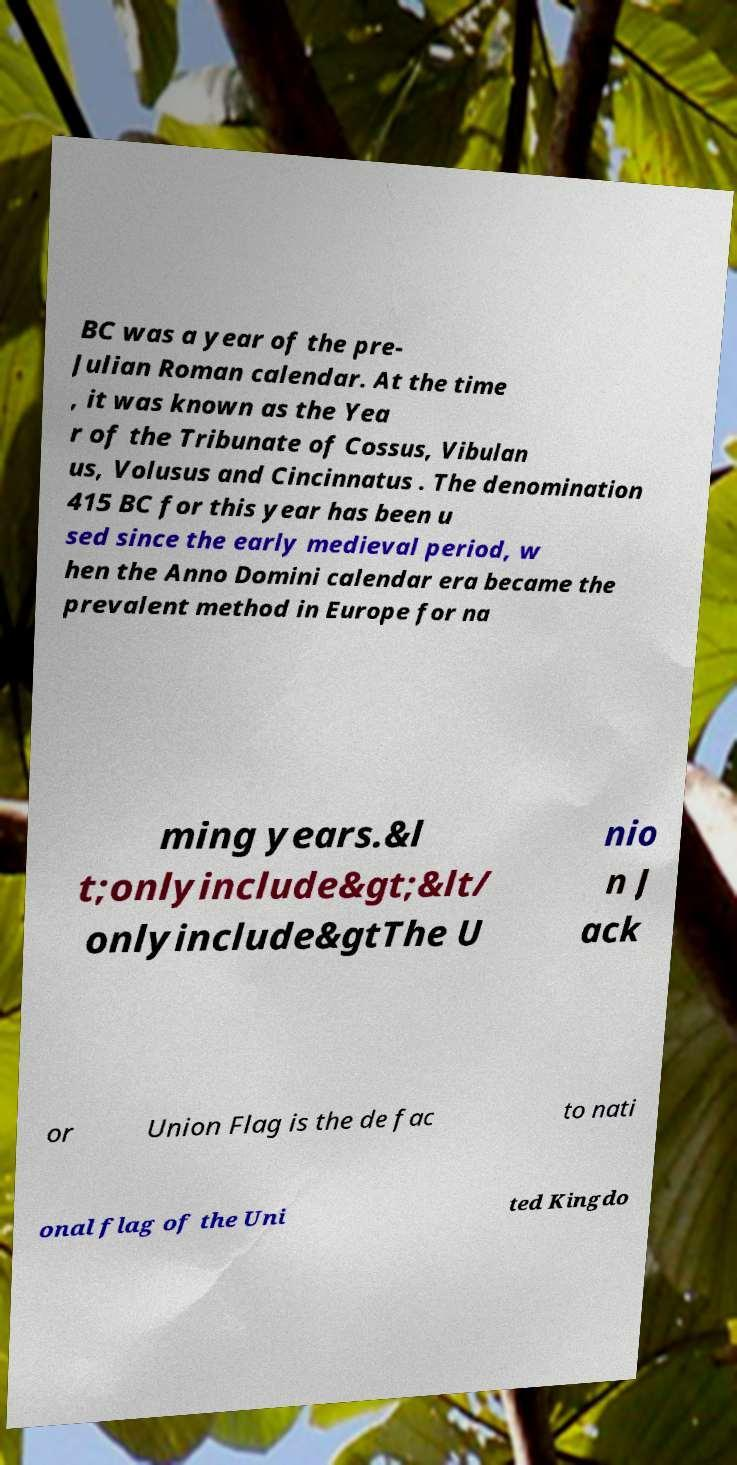Could you assist in decoding the text presented in this image and type it out clearly? BC was a year of the pre- Julian Roman calendar. At the time , it was known as the Yea r of the Tribunate of Cossus, Vibulan us, Volusus and Cincinnatus . The denomination 415 BC for this year has been u sed since the early medieval period, w hen the Anno Domini calendar era became the prevalent method in Europe for na ming years.&l t;onlyinclude&gt;&lt/ onlyinclude&gtThe U nio n J ack or Union Flag is the de fac to nati onal flag of the Uni ted Kingdo 